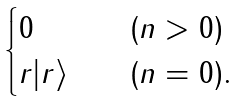<formula> <loc_0><loc_0><loc_500><loc_500>\begin{cases} 0 & \quad ( n > 0 ) \\ r | r \rangle & \quad ( n = 0 ) . \end{cases}</formula> 